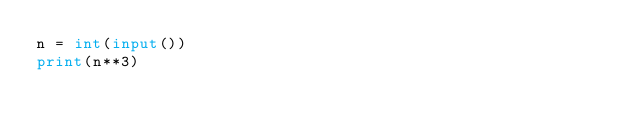<code> <loc_0><loc_0><loc_500><loc_500><_Python_>n = int(input())
print(n**3)</code> 